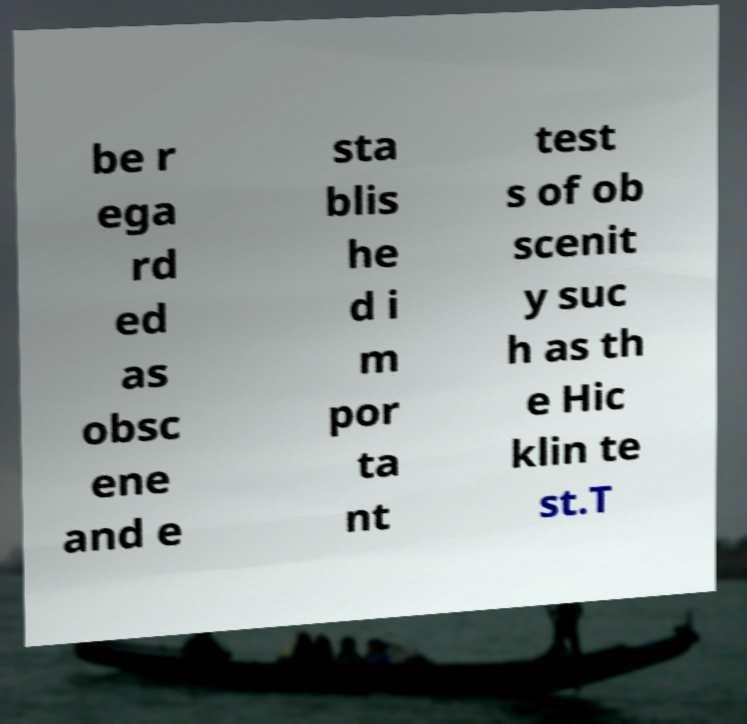I need the written content from this picture converted into text. Can you do that? be r ega rd ed as obsc ene and e sta blis he d i m por ta nt test s of ob scenit y suc h as th e Hic klin te st.T 